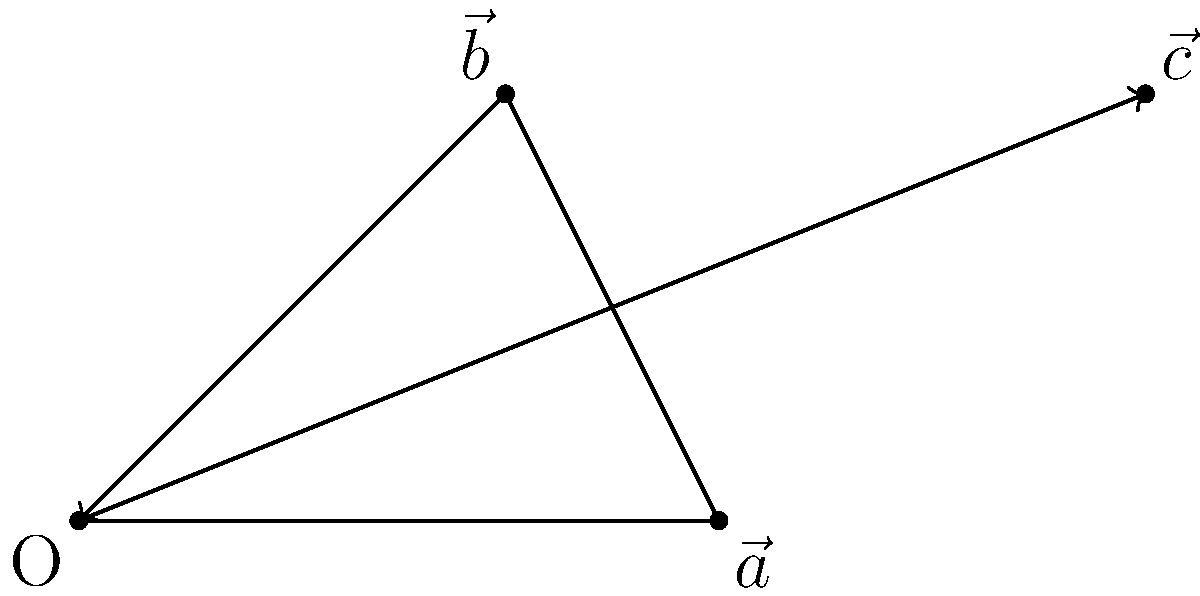In representing the impact of legal assistance on case outcomes, consider the vector diagram above. Vector $\vec{a}$ represents the initial likelihood of a favorable outcome without legal assistance, $\vec{b}$ represents the additional impact of providing legal resources, and $\vec{c}$ represents the final outcome probability with full legal assistance. If $\vec{a} = 3\hat{i}$, $\vec{b} = 2\hat{i} + 2\hat{j}$, what is the magnitude of $\vec{c}$? To solve this problem, we'll follow these steps:

1) We know that $\vec{c} = \vec{a} + \vec{b}$ (vector addition)

2) Given:
   $\vec{a} = 3\hat{i}$
   $\vec{b} = 2\hat{i} + 2\hat{j}$

3) Let's add these vectors:
   $\vec{c} = (3\hat{i}) + (2\hat{i} + 2\hat{j})$
   $\vec{c} = 5\hat{i} + 2\hat{j}$

4) To find the magnitude of $\vec{c}$, we use the Pythagorean theorem:
   $|\vec{c}| = \sqrt{(5)^2 + (2)^2}$

5) Simplify:
   $|\vec{c}| = \sqrt{25 + 4} = \sqrt{29}$

Therefore, the magnitude of $\vec{c}$, representing the final outcome probability with full legal assistance, is $\sqrt{29}$.
Answer: $\sqrt{29}$ 